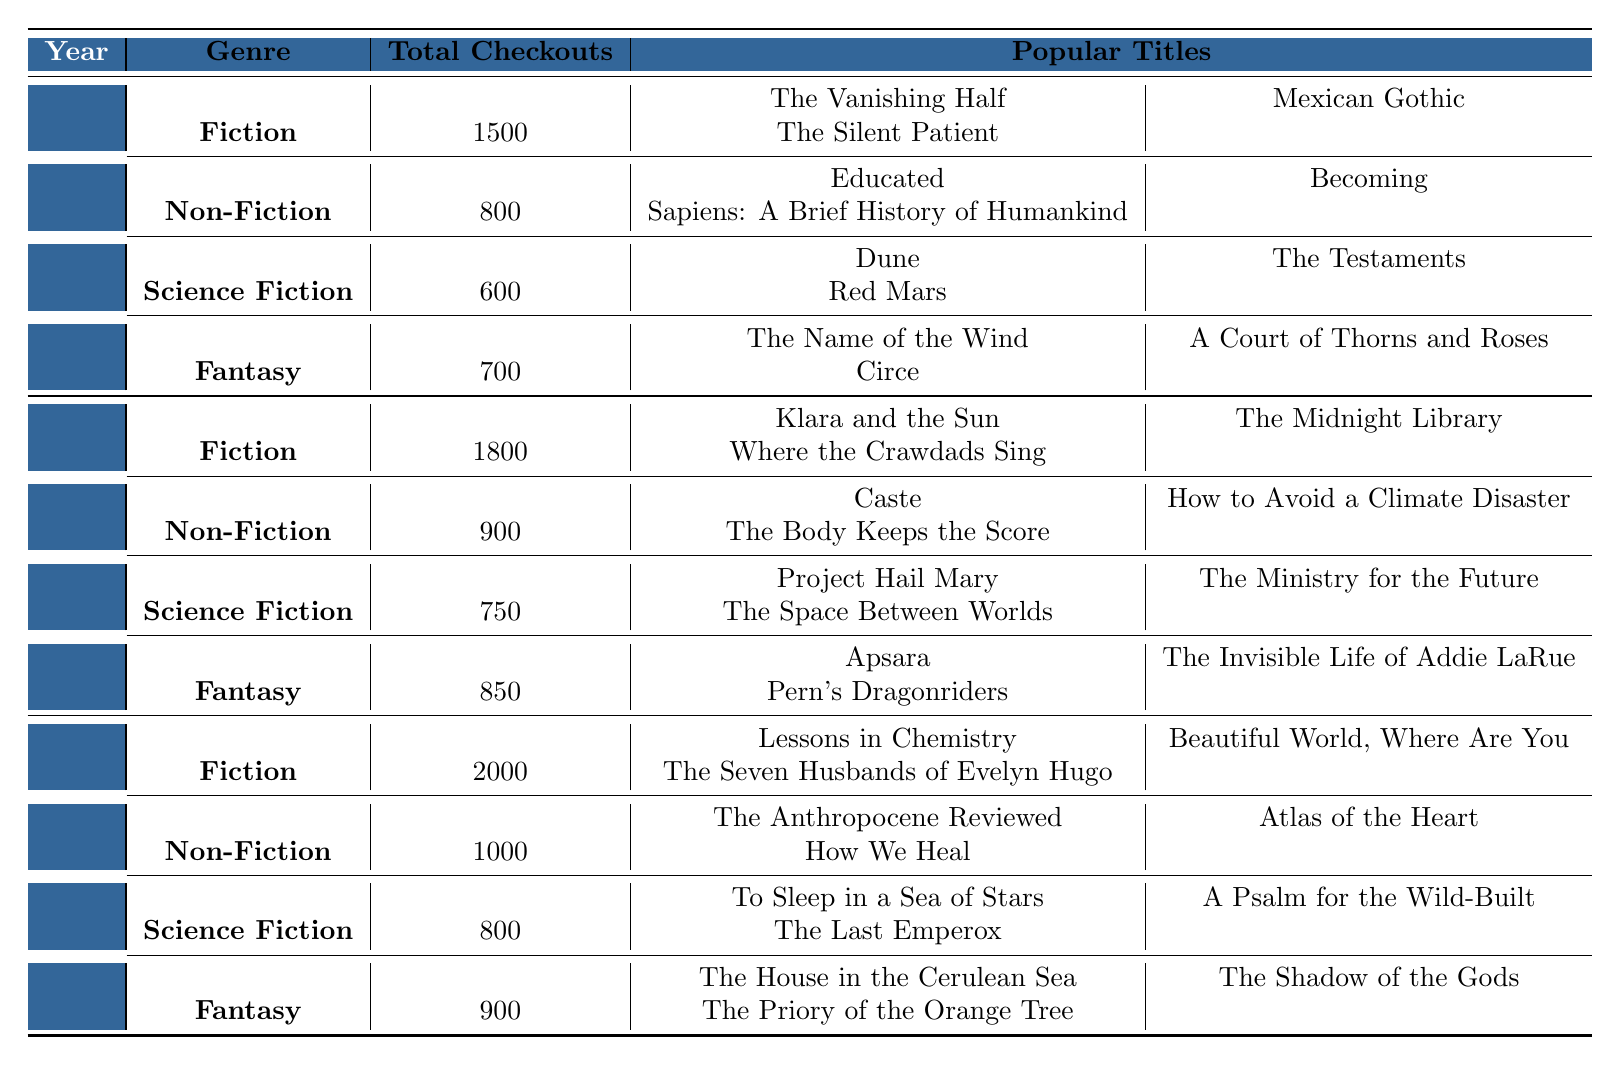What was the total number of checkouts for Fiction in 2021? The table lists the total checkouts for Fiction in 2021 under the year "2021" and genre "Fiction." The value is 1800.
Answer: 1800 Which genre had the highest total checkouts in 2022? In 2022, the Fiction genre had the highest checkouts at 2000 when comparing the total checkouts across all genres for that year.
Answer: Fiction Is it true that the total checkouts for Non-Fiction in 2020 were greater than in 2021? The total checkouts for Non-Fiction in 2020 was 800, and in 2021 it was 900. Since 800 is less than 900, the statement is false.
Answer: No What is the average number of checkouts for Fantasy across all three years? The total checkouts for Fantasy are: 700 (2020) + 850 (2021) + 900 (2022) = 2450. There are 3 years so the average is 2450 / 3 = 816.67.
Answer: 816.67 How many popular titles are listed for Science Fiction in 2022? The table shows that there are three popular titles listed for Science Fiction in 2022: "To Sleep in a Sea of Stars," "A Psalm for the Wild-Built," and "The Last Emperox." Therefore, the count is 3.
Answer: 3 In which year did Non-Fiction first exceed 900 checkouts? For Non-Fiction, the total checkouts in 2020 were 800 and in 2021 were 900, but it first exceeded 900 in 2022 when the total was 1000.
Answer: 2022 What are the two most popular titles for Fiction in 2022? The table lists three popular titles for Fiction in 2022. The two most popular titles are "Lessons in Chemistry" and "Beautiful World, Where Are You" based on their order in the list.
Answer: Lessons in Chemistry, Beautiful World, Where Are You Which genre had fewer total checkouts in 2020 compared to 2021, and what was the total for each year? In the table, Science Fiction had 600 checkouts in 2020 and 750 in 2021. Since 600 is fewer than 750, Science Fiction is the genre with fewer checkouts in 2020 compared to 2021.
Answer: Science Fiction: 600 in 2020, 750 in 2021 